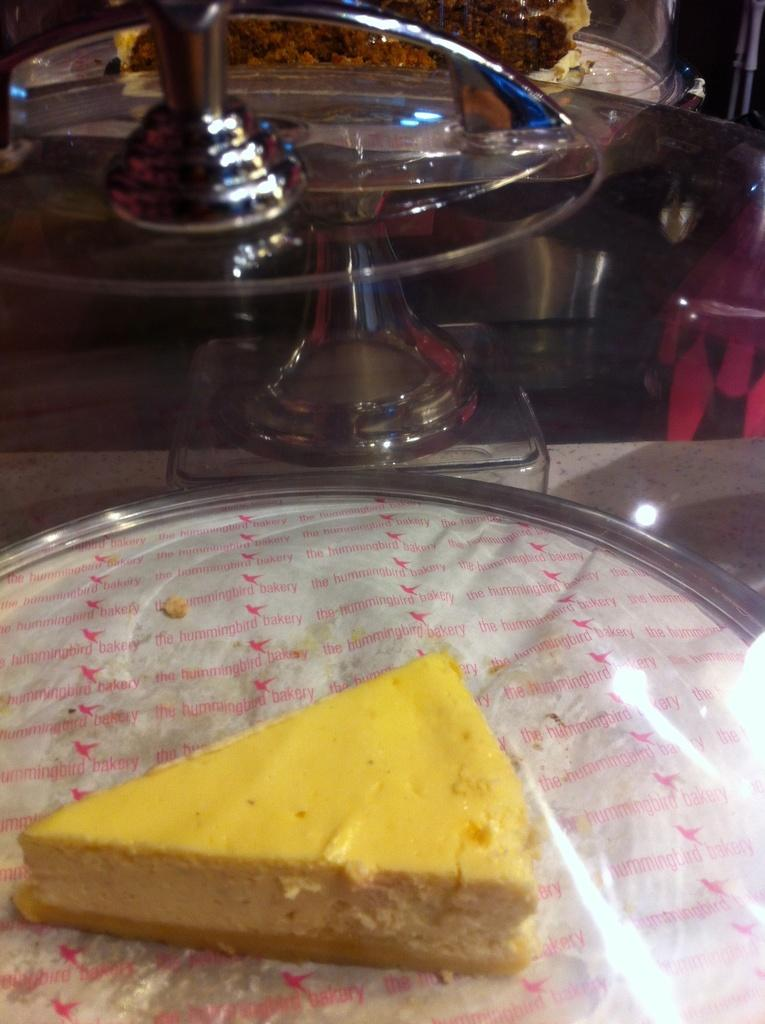What type of dessert is on the steel plate in the image? There is a yellow piece of cake on a steel plate in the image. What is inside the glass box on the table? The facts provided do not mention anything inside the glass box, so we cannot answer this question definitively. What is on the table besides the glass box? There is a plate on the table. What type of seating is near the round table? There is a chair near a round table. What shape is the floor in the image? The facts provided do not mention the shape of the floor, so we cannot answer this question definitively. 